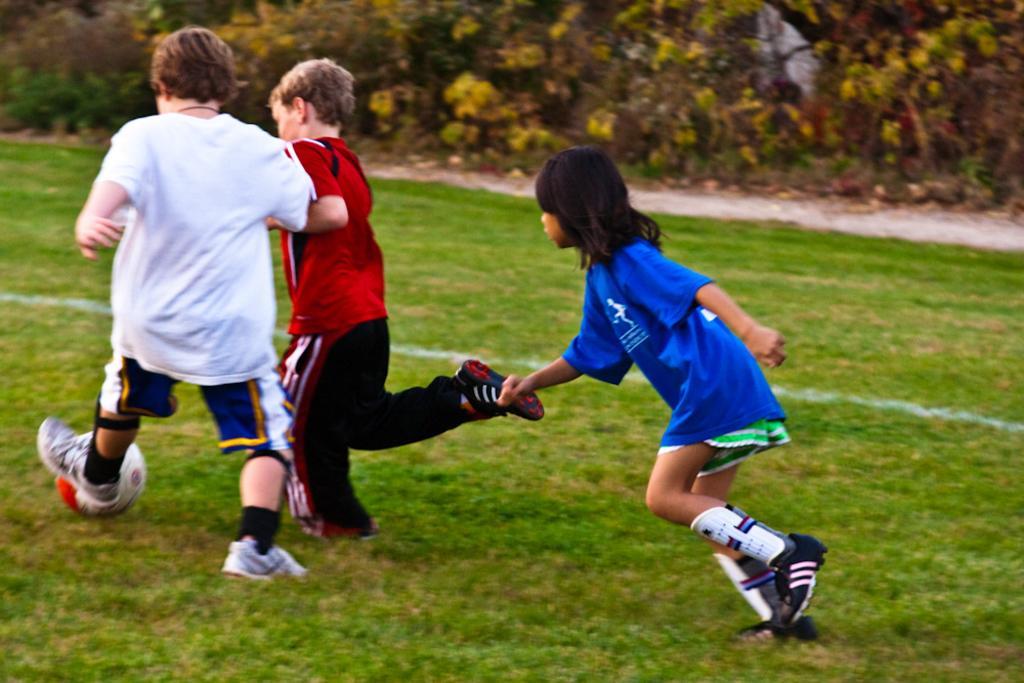In one or two sentences, can you explain what this image depicts? In this image, we can see three kids are playing a game with a ball on the grass. Top of the image, we can see plants. 